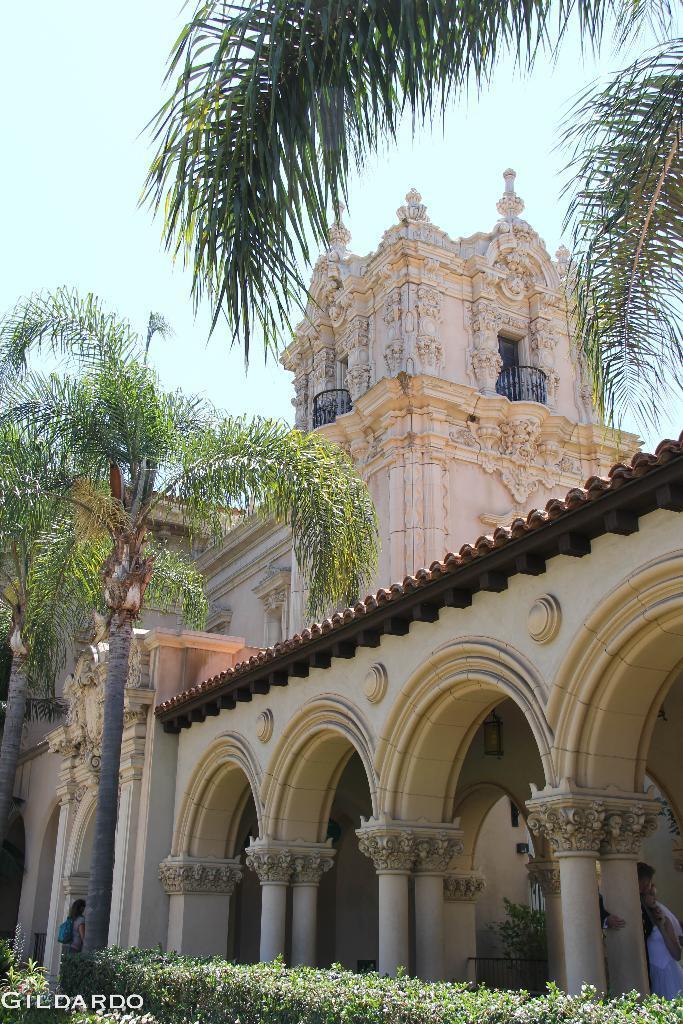Please provide a concise description of this image. In this picture we can see a building and some people. In front of the building there are trees and a hedge. Behind the building there is the sky. On the image there is a watermark. 